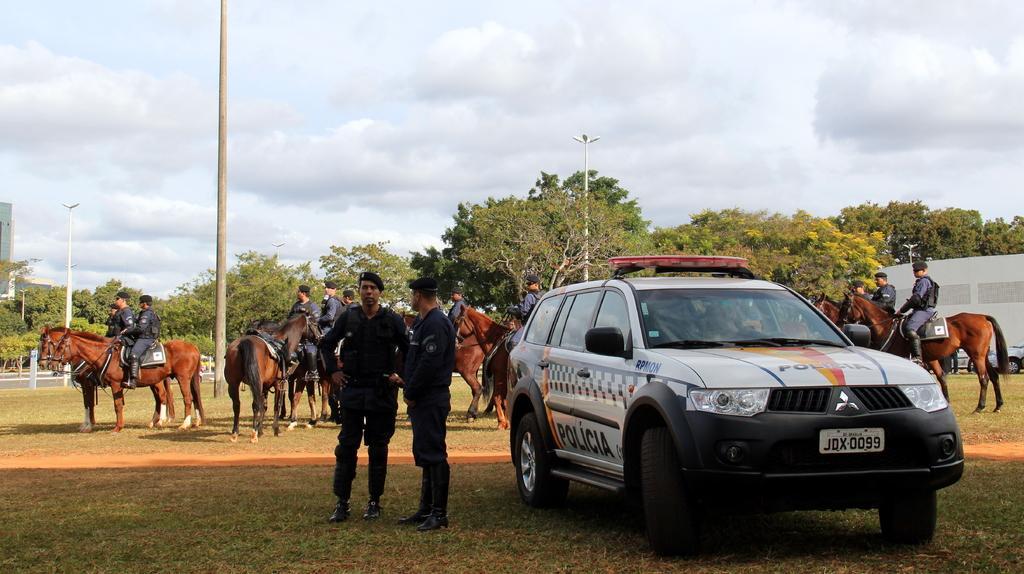In one or two sentences, can you explain what this image depicts? In this image on the right there is a car. Beside it there are two men. In the background there are many people sitting on horses. In the back there are trees, buildings, poles. The sky is cloudy. 